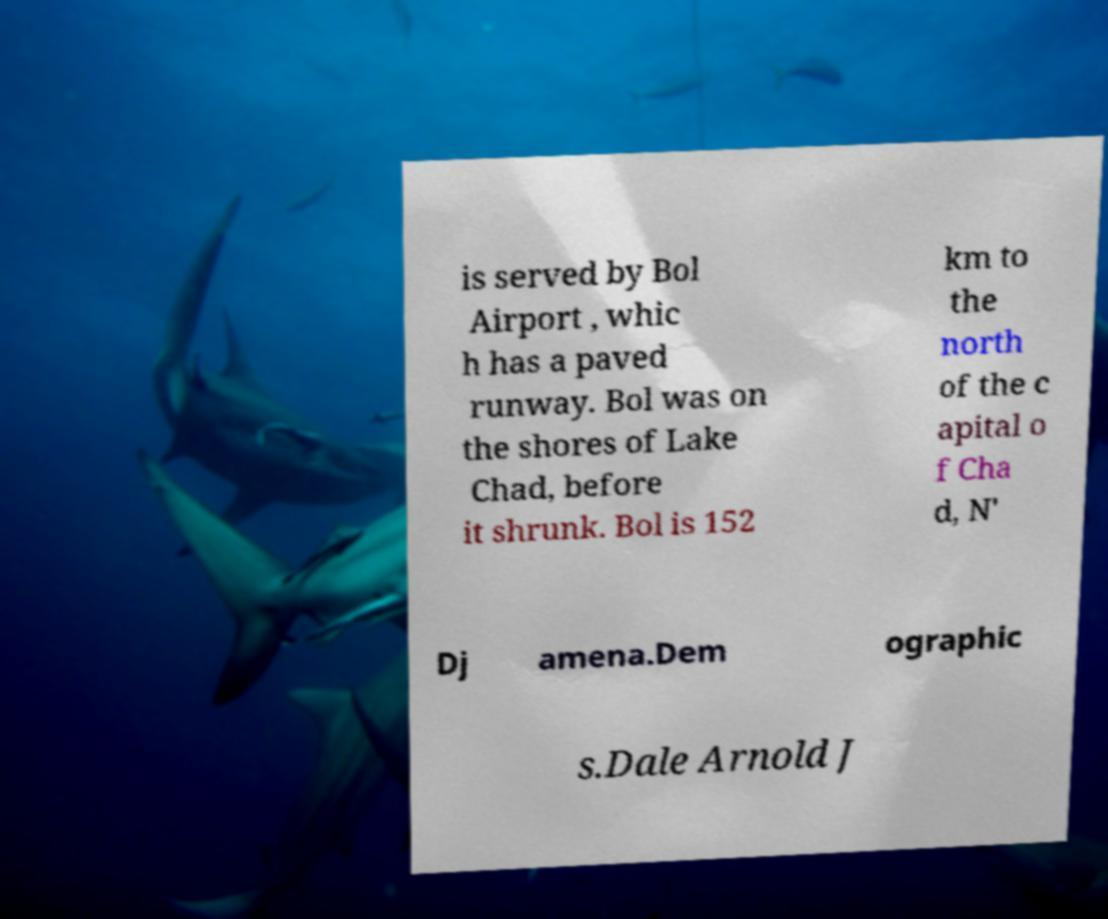There's text embedded in this image that I need extracted. Can you transcribe it verbatim? is served by Bol Airport , whic h has a paved runway. Bol was on the shores of Lake Chad, before it shrunk. Bol is 152 km to the north of the c apital o f Cha d, N' Dj amena.Dem ographic s.Dale Arnold J 